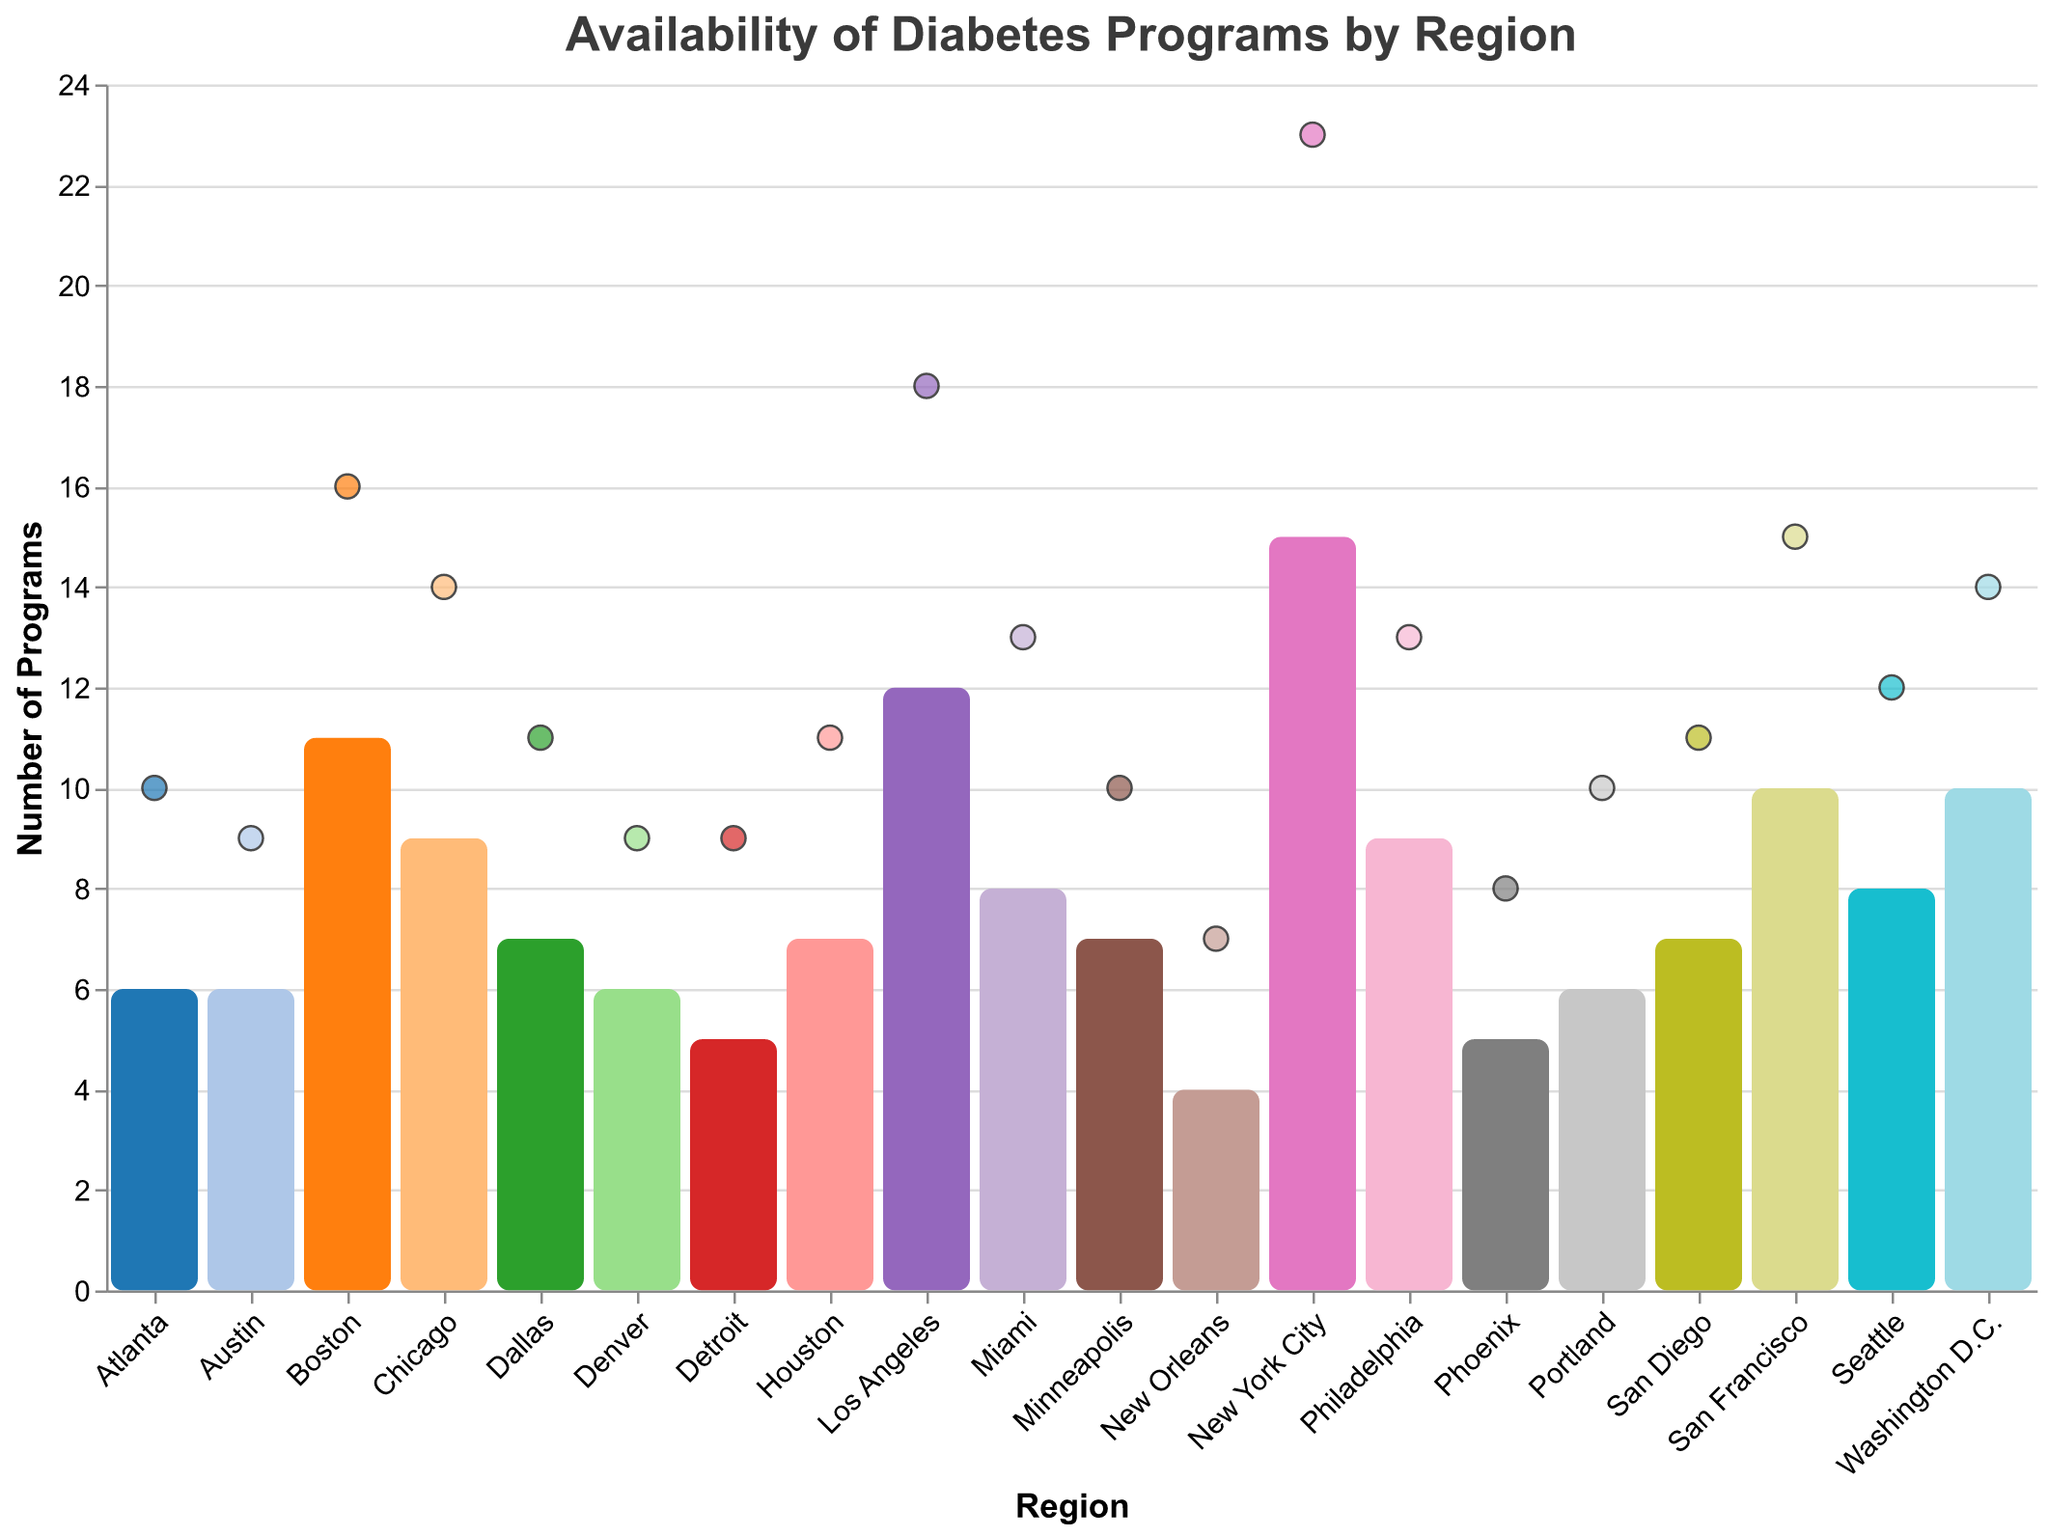What is the title of the figure? The title of the figure is typically displayed at the top and summarizes the main theme or focus of the visualization. In this case, the title is "Availability of Diabetes Programs by Region."
Answer: Availability of Diabetes Programs by Region How many regions are represented in the figure? To find out the number of regions represented, count the distinct elements on the x-axis or the individual colored bars in the figure. Here, there are bars corresponding to different regions.
Answer: 20 Which region has the highest number of Education Programs? Check the height of the bars representing Education Programs for each region. The tallest bar indicates the highest number of such programs. New York City has the tallest bar here.
Answer: New York City Which region has more Support Groups, Chicago or Miami? Look for the circle markers representing Support Groups for both Chicago and Miami. Chicago has 14 support groups, whereas Miami has 13.
Answer: Chicago What is the average number of Education Programs across all regions? Calculate the average by summing up the number of Education Programs for all regions and then dividing by the total number of regions. (15 + 12 + 9 + 7 + 8 + 11 + 10 + 8 + 6 + 7 + 6 + 5 + 7 + 9 + 10 + 4 + 5 + 6 + 7 + 6) / 20 = 8.1
Answer: 8.1 Which region has the lowest number of Support Groups? Find the circle marker positioned lowest on the y-axis for Support Groups. New Orleans has the lowest support group count.
Answer: New Orleans What is the total number of Support Groups in Los Angeles and San Francisco combined? Add the number of Support Groups for both Los Angeles and San Francisco. Los Angeles has 18 and San Francisco has 15, so 18 + 15 = 33.
Answer: 33 How many more Support Groups does Washington D.C. have compared to Phoenix? Subtract the number of Support Groups in Phoenix from those in Washington D.C. Washington D.C. has 14 and Phoenix has 8, so 14 - 8 = 6.
Answer: 6 What is the difference in the number of Education Programs between New York City and Detroit? Subtract the number of Education Programs in Detroit from those in New York City. New York City has 15 and Detroit has 5, so 15 - 5 = 10.
Answer: 10 Which region has an equal number of Education Programs and Support Groups? Compare the numbers of Education Programs and Support Groups for each region. Denver is the region where both counts are equal, having 6 of each.
Answer: Denver 